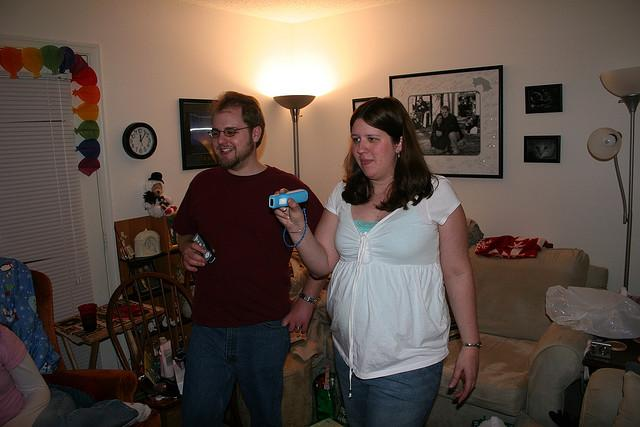What session of the day is it?

Choices:
A) midnight
B) evening
C) morning
D) afternoon midnight 